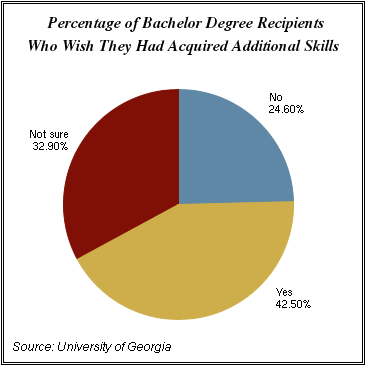Identify some key points in this picture. The difference between the two largest segments is 0.096. The smallest segment is blue in color. 